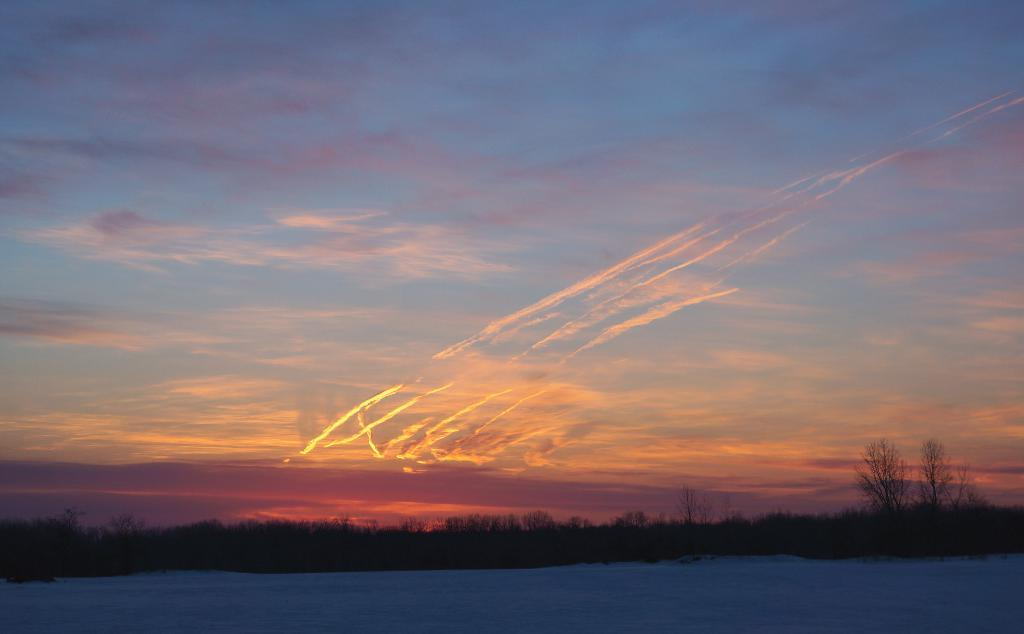What is the main subject of the image? The main subject of the image is a white surface with snow. What can be seen in the background of the image? In the background, there are plants and trees visible. How would you describe the overall color scheme of the background? The background is dark. What is visible in the sky in the image? Sun rays are present in the sky. What direction is the metal object pointing in the image? There is no metal object present in the image. 